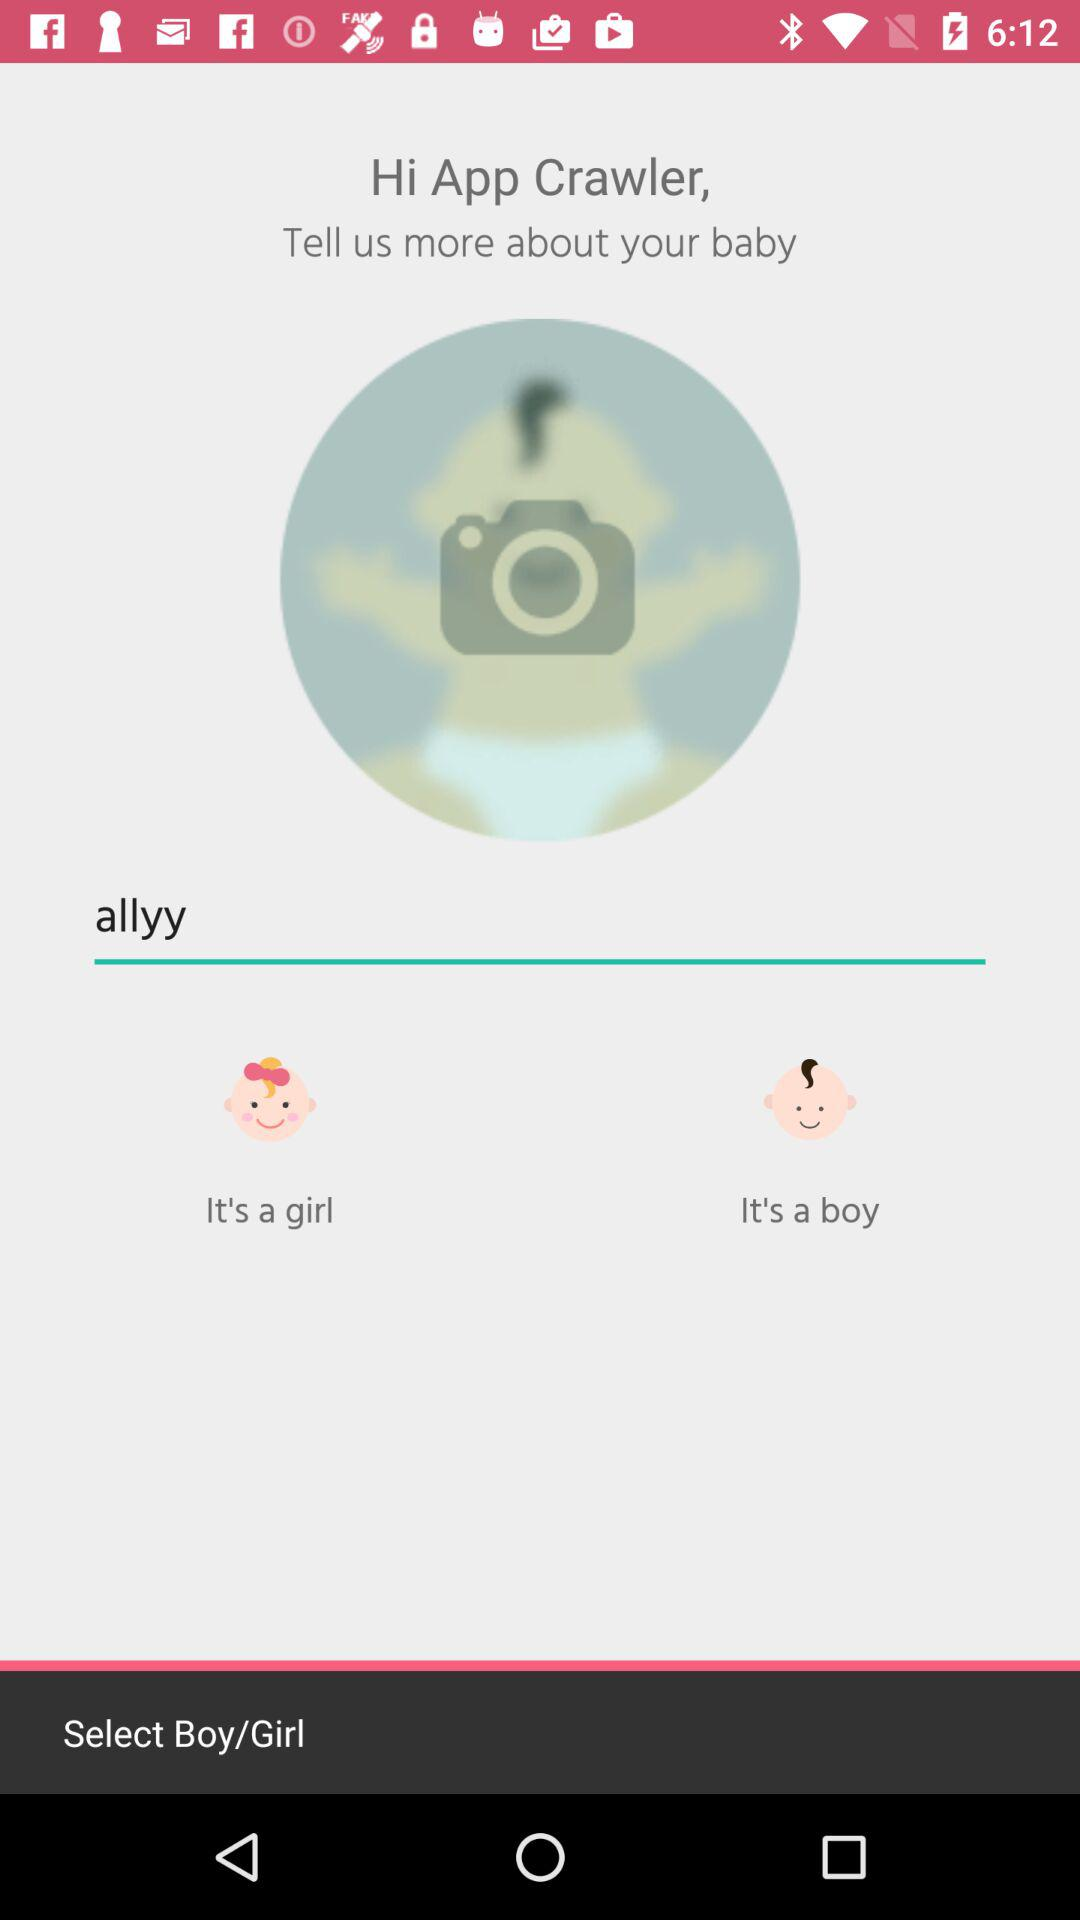What is the user name? The user name is App Crawler. 